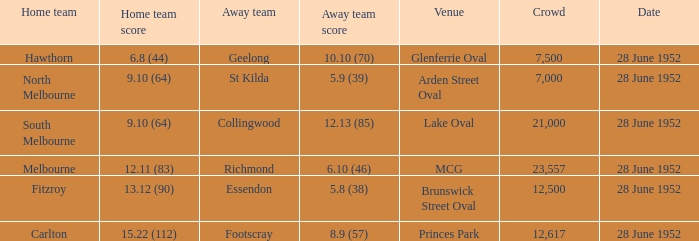Who is the away side when north melbourne is at home and has a score of 9.10 (64)? St Kilda. 